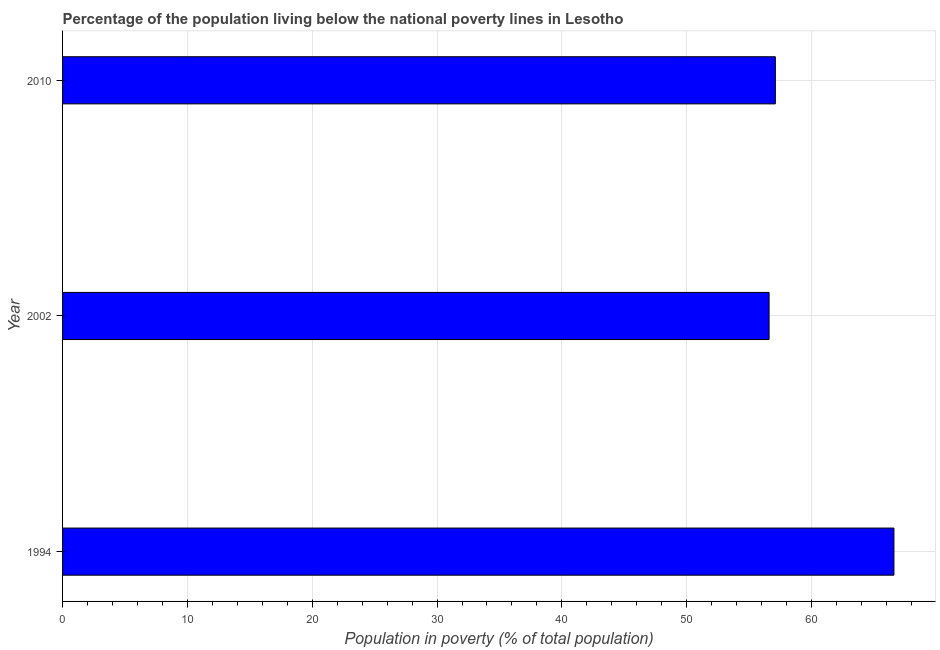What is the title of the graph?
Offer a terse response. Percentage of the population living below the national poverty lines in Lesotho. What is the label or title of the X-axis?
Offer a very short reply. Population in poverty (% of total population). What is the label or title of the Y-axis?
Make the answer very short. Year. What is the percentage of population living below poverty line in 1994?
Your response must be concise. 66.6. Across all years, what is the maximum percentage of population living below poverty line?
Give a very brief answer. 66.6. Across all years, what is the minimum percentage of population living below poverty line?
Give a very brief answer. 56.6. In which year was the percentage of population living below poverty line maximum?
Offer a terse response. 1994. What is the sum of the percentage of population living below poverty line?
Ensure brevity in your answer.  180.3. What is the difference between the percentage of population living below poverty line in 1994 and 2010?
Make the answer very short. 9.5. What is the average percentage of population living below poverty line per year?
Make the answer very short. 60.1. What is the median percentage of population living below poverty line?
Offer a very short reply. 57.1. In how many years, is the percentage of population living below poverty line greater than 42 %?
Make the answer very short. 3. Do a majority of the years between 2002 and 1994 (inclusive) have percentage of population living below poverty line greater than 38 %?
Offer a very short reply. No. Is the difference between the percentage of population living below poverty line in 2002 and 2010 greater than the difference between any two years?
Give a very brief answer. No. What is the difference between the highest and the second highest percentage of population living below poverty line?
Ensure brevity in your answer.  9.5. In how many years, is the percentage of population living below poverty line greater than the average percentage of population living below poverty line taken over all years?
Your response must be concise. 1. Are all the bars in the graph horizontal?
Offer a terse response. Yes. How many years are there in the graph?
Offer a terse response. 3. Are the values on the major ticks of X-axis written in scientific E-notation?
Offer a very short reply. No. What is the Population in poverty (% of total population) of 1994?
Your answer should be compact. 66.6. What is the Population in poverty (% of total population) of 2002?
Make the answer very short. 56.6. What is the Population in poverty (% of total population) of 2010?
Offer a terse response. 57.1. What is the difference between the Population in poverty (% of total population) in 1994 and 2002?
Provide a succinct answer. 10. What is the difference between the Population in poverty (% of total population) in 1994 and 2010?
Offer a terse response. 9.5. What is the ratio of the Population in poverty (% of total population) in 1994 to that in 2002?
Offer a terse response. 1.18. What is the ratio of the Population in poverty (% of total population) in 1994 to that in 2010?
Make the answer very short. 1.17. 